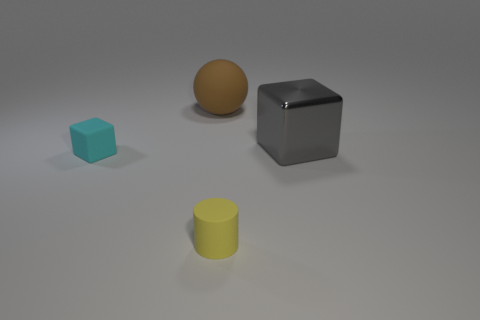Add 1 brown matte spheres. How many objects exist? 5 Subtract all cyan cubes. How many cubes are left? 1 Subtract all cylinders. How many objects are left? 3 Subtract 1 cubes. How many cubes are left? 1 Subtract all green cylinders. Subtract all blue spheres. How many cylinders are left? 1 Add 4 matte objects. How many matte objects are left? 7 Add 1 purple metal things. How many purple metal things exist? 1 Subtract 0 blue cylinders. How many objects are left? 4 Subtract all purple blocks. How many gray spheres are left? 0 Subtract all purple metallic cylinders. Subtract all cyan blocks. How many objects are left? 3 